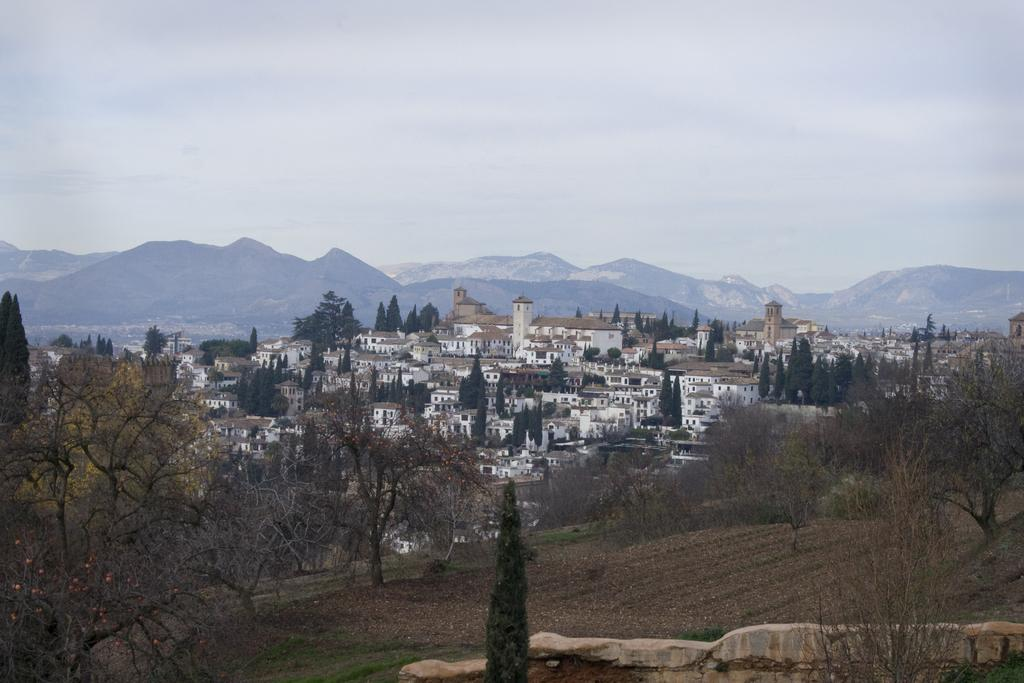What type of natural elements can be seen in the image? There are trees in the image. What type of man-made structures are present in the image? There are buildings in the image. What geographical features can be seen in the background of the image? There are mountains visible in the background of the image. What is the condition of the sky in the background of the image? The sky is clear in the background of the image. What type of meat can be seen hanging from the trees in the image? There is no meat present in the image; it features trees, buildings, mountains, and a clear sky. Can you tell me how many people are running in the image? There are no people running in the image; it is a landscape scene with trees, buildings, mountains, and a clear sky. 